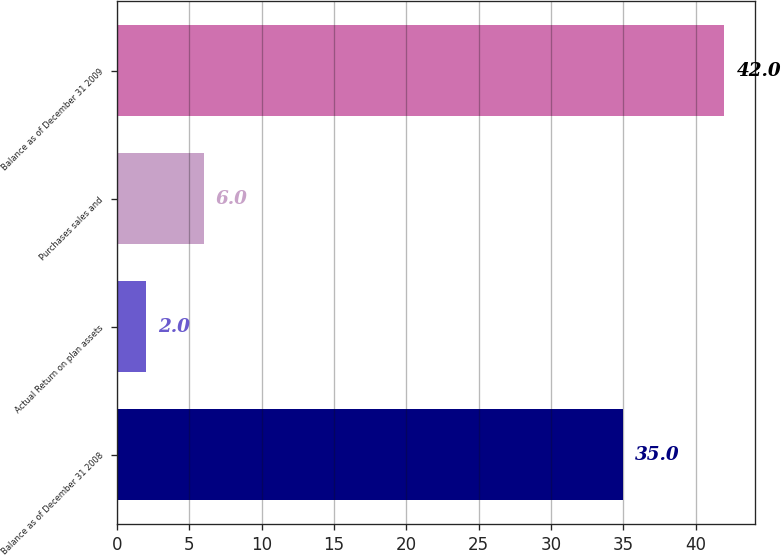Convert chart to OTSL. <chart><loc_0><loc_0><loc_500><loc_500><bar_chart><fcel>Balance as of December 31 2008<fcel>Actual Return on plan assets<fcel>Purchases sales and<fcel>Balance as of December 31 2009<nl><fcel>35<fcel>2<fcel>6<fcel>42<nl></chart> 